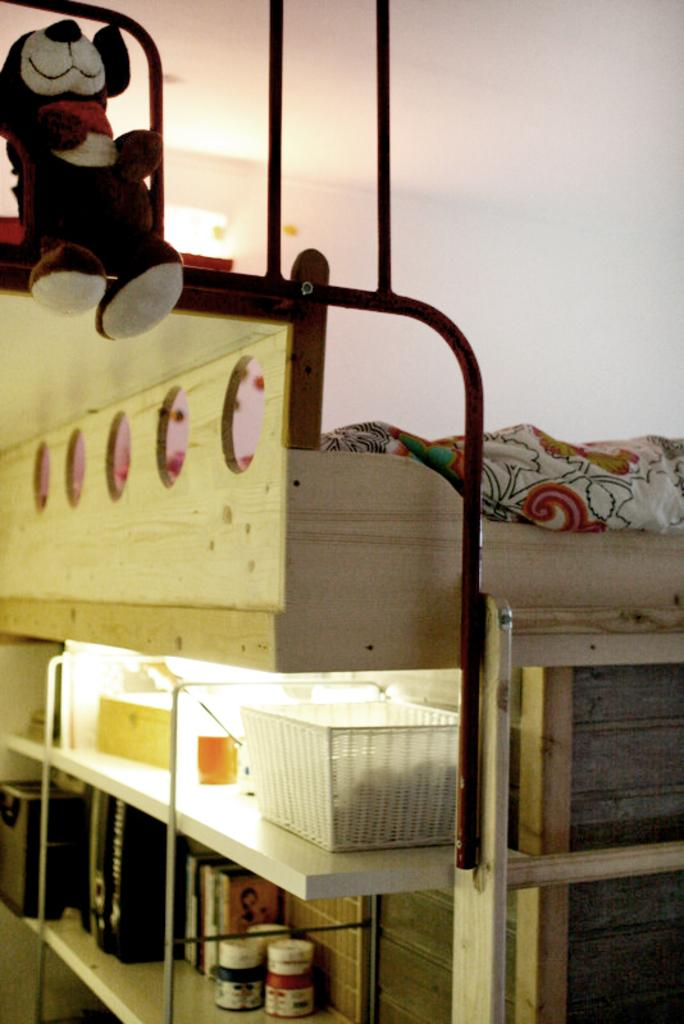What is stored in the rack in the image? There is a bottle in the rack in the image. What is hanging from the rod in the image? There is a teddy bear on the rod in the image. What is the material of the object on the rod? The teddy bear is made of cloth. What is stored in the shelf in the image? There is a cup and a deck in the shelf in the image. Can you see a letter addressed to the teddy bear in the image? There is no letter present in the image; it only features a teddy bear on the rod. Is there a pail filled with water next to the teddy bear? There is no pail visible in the image; it only features a teddy bear on the rod and other objects in the rack and shelf. 